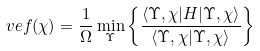<formula> <loc_0><loc_0><loc_500><loc_500>\ v e f ( \chi ) = \frac { 1 } { \Omega } \min _ { \Upsilon } \left \{ \frac { \langle \Upsilon , \chi | H | \Upsilon , \chi \rangle } { \langle \Upsilon , \chi | \Upsilon , \chi \rangle } \right \}</formula> 